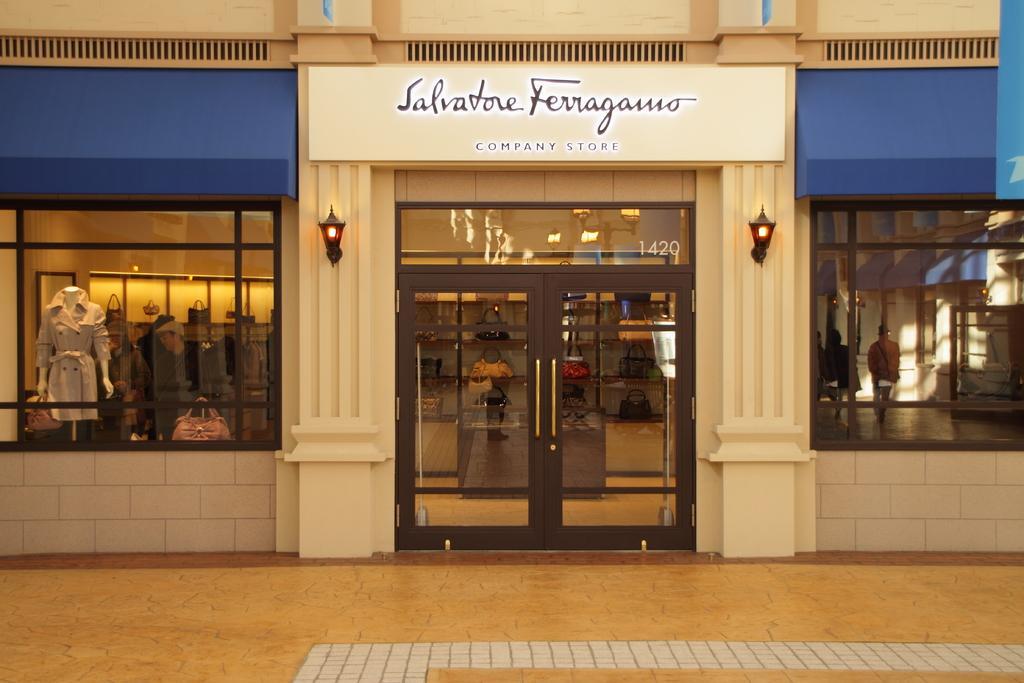In one or two sentences, can you explain what this image depicts? In this image in the center there is one store, in that store there are some clothes, handbags and some persons are walking. At the bottom there is a floor and on the top of the image there is some text. 